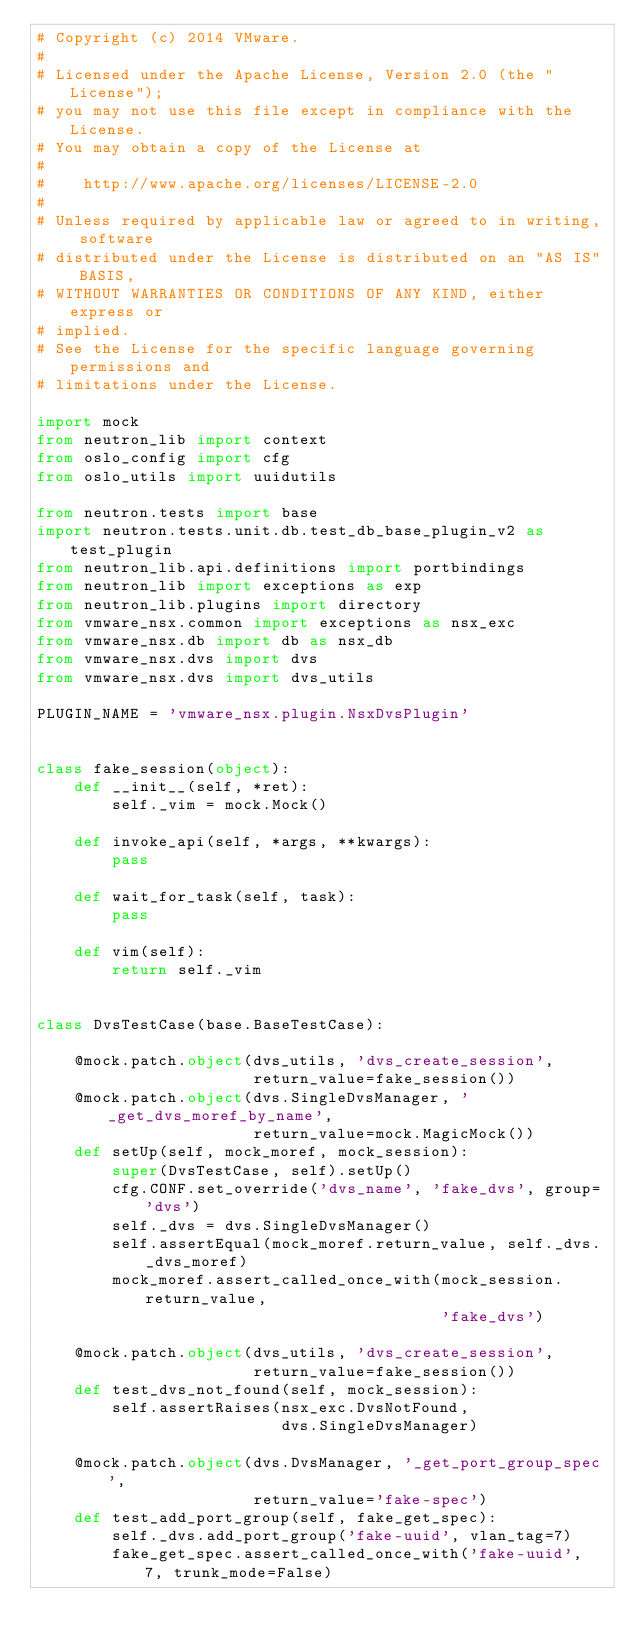Convert code to text. <code><loc_0><loc_0><loc_500><loc_500><_Python_># Copyright (c) 2014 VMware.
#
# Licensed under the Apache License, Version 2.0 (the "License");
# you may not use this file except in compliance with the License.
# You may obtain a copy of the License at
#
#    http://www.apache.org/licenses/LICENSE-2.0
#
# Unless required by applicable law or agreed to in writing, software
# distributed under the License is distributed on an "AS IS" BASIS,
# WITHOUT WARRANTIES OR CONDITIONS OF ANY KIND, either express or
# implied.
# See the License for the specific language governing permissions and
# limitations under the License.

import mock
from neutron_lib import context
from oslo_config import cfg
from oslo_utils import uuidutils

from neutron.tests import base
import neutron.tests.unit.db.test_db_base_plugin_v2 as test_plugin
from neutron_lib.api.definitions import portbindings
from neutron_lib import exceptions as exp
from neutron_lib.plugins import directory
from vmware_nsx.common import exceptions as nsx_exc
from vmware_nsx.db import db as nsx_db
from vmware_nsx.dvs import dvs
from vmware_nsx.dvs import dvs_utils

PLUGIN_NAME = 'vmware_nsx.plugin.NsxDvsPlugin'


class fake_session(object):
    def __init__(self, *ret):
        self._vim = mock.Mock()

    def invoke_api(self, *args, **kwargs):
        pass

    def wait_for_task(self, task):
        pass

    def vim(self):
        return self._vim


class DvsTestCase(base.BaseTestCase):

    @mock.patch.object(dvs_utils, 'dvs_create_session',
                       return_value=fake_session())
    @mock.patch.object(dvs.SingleDvsManager, '_get_dvs_moref_by_name',
                       return_value=mock.MagicMock())
    def setUp(self, mock_moref, mock_session):
        super(DvsTestCase, self).setUp()
        cfg.CONF.set_override('dvs_name', 'fake_dvs', group='dvs')
        self._dvs = dvs.SingleDvsManager()
        self.assertEqual(mock_moref.return_value, self._dvs._dvs_moref)
        mock_moref.assert_called_once_with(mock_session.return_value,
                                           'fake_dvs')

    @mock.patch.object(dvs_utils, 'dvs_create_session',
                       return_value=fake_session())
    def test_dvs_not_found(self, mock_session):
        self.assertRaises(nsx_exc.DvsNotFound,
                          dvs.SingleDvsManager)

    @mock.patch.object(dvs.DvsManager, '_get_port_group_spec',
                       return_value='fake-spec')
    def test_add_port_group(self, fake_get_spec):
        self._dvs.add_port_group('fake-uuid', vlan_tag=7)
        fake_get_spec.assert_called_once_with('fake-uuid', 7, trunk_mode=False)
</code> 